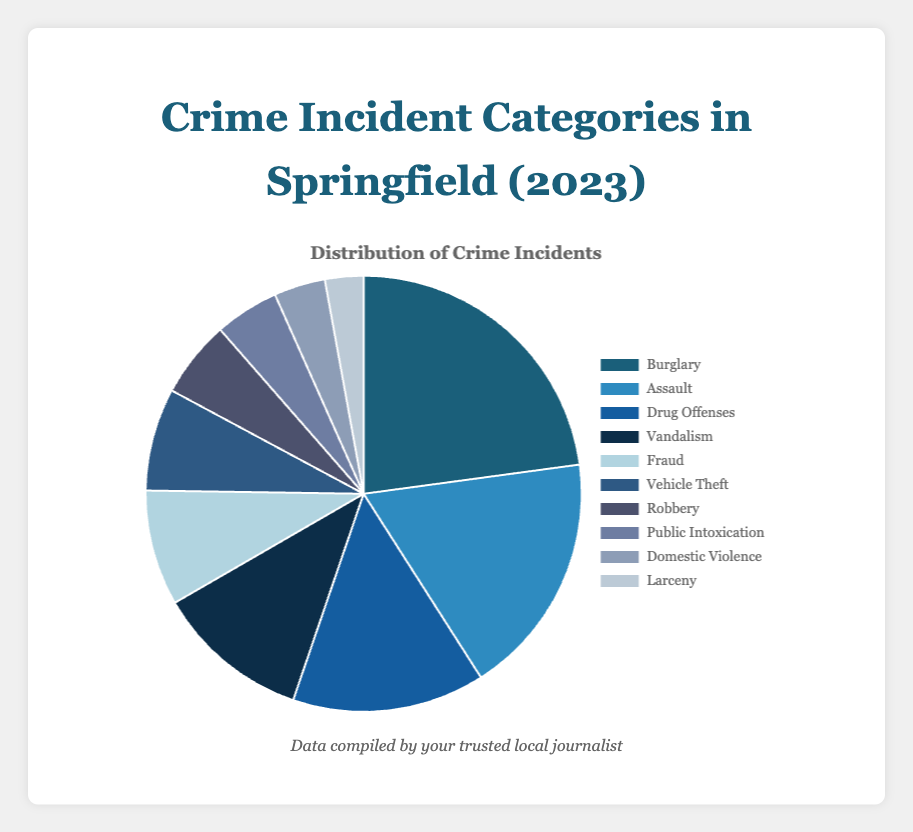What is the most common crime incident category in Springfield for 2023? The most common crime category is the one with the highest number of incidents. From the data, Burglary has the highest number of incidents at 120.
Answer: Burglary Which crime incident category has the fewest incidents? The category with the fewest incidents is the one with the lowest number. From the data, Larceny has 15 incidents, which is the least.
Answer: Larceny What is the total number of crime incidents in Springfield over the past year? To find the total number of crime incidents, we need to sum the incidents of all categories: 120 + 95 + 75 + 60 + 45 + 40 + 30 + 25 + 20 + 15 = 525.
Answer: 525 How many more incidents of Burglary are there compared to Vehicle Theft? Burglary had 120 incidents while Vehicle Theft had 40. The difference between them is 120 - 40 = 80.
Answer: 80 What percentage of the total incidents does Assault represent? First, find the total number of incidents: 525. Then, calculate the percentage for Assault (95 incidents): (95 / 525) * 100 ≈ 18.1%.
Answer: 18.1% Which category has more incidents: Public Intoxication or Domestic Violence? Public Intoxication has 25 incidents and Domestic Violence has 20 incidents. Therefore, Public Intoxication has more incidents.
Answer: Public Intoxication How many incidents are related to non-violent crimes (Drug Offenses, Fraud, Vehicle Theft, and Larceny)? Sum the incidents for non-violent crime categories: 75 (Drug Offenses) + 45 (Fraud) + 40 (Vehicle Theft) + 15 (Larceny) = 175.
Answer: 175 How many fewer incidents were there of Robbery compared to Vandalism? Robbery had 30 incidents while Vandalism had 60 incidents. The difference is 60 - 30 = 30.
Answer: 30 What's the average number of incidents per category? To find the average, sum up all incidents and divide by the number of categories: 525 incidents / 10 categories = 52.5 incidents per category.
Answer: 52.5 Which category is represented by a blue color in the pie chart? Examining the data provided, Assault is likely represented by one of the blue shades.
Answer: Assault 